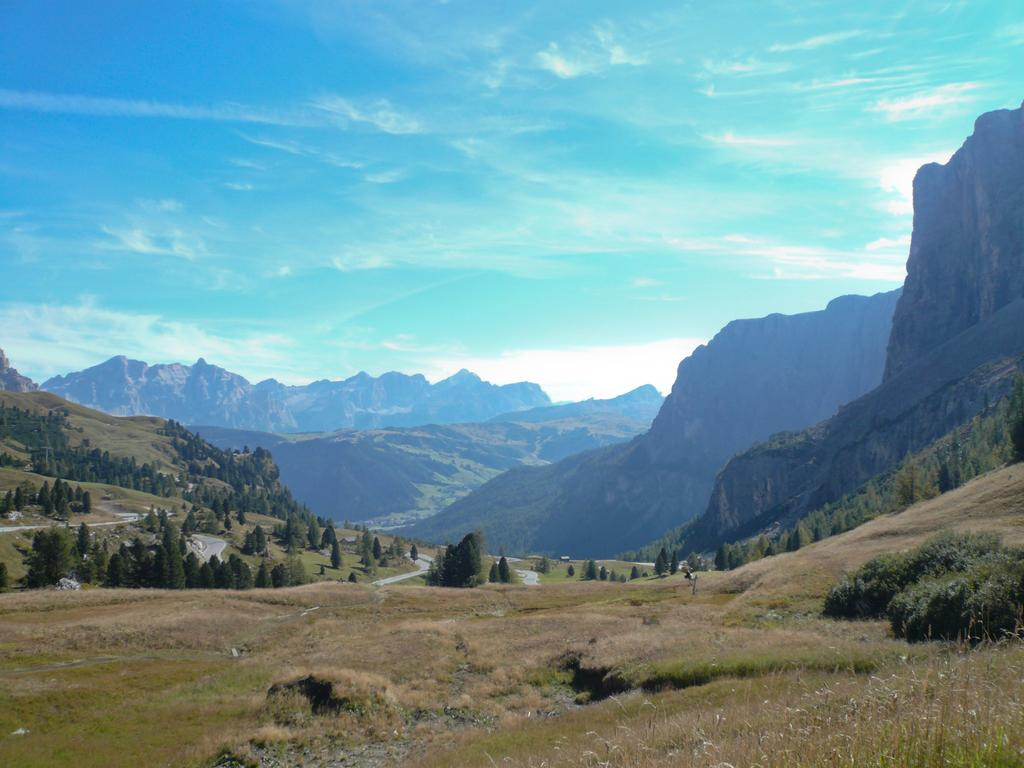What type of vegetation can be seen in the image? There is grass, plants, and trees in the image. What type of man-made structures are present in the image? There are roads in the image. What type of natural feature can be seen in the image? There are hills in the image. What part of the natural environment is visible in the image? The sky is visible in the image. What type of music can be heard coming from the harbor in the image? There is no harbor present in the image, so it's not possible to determine what, if any, music might be heard. 